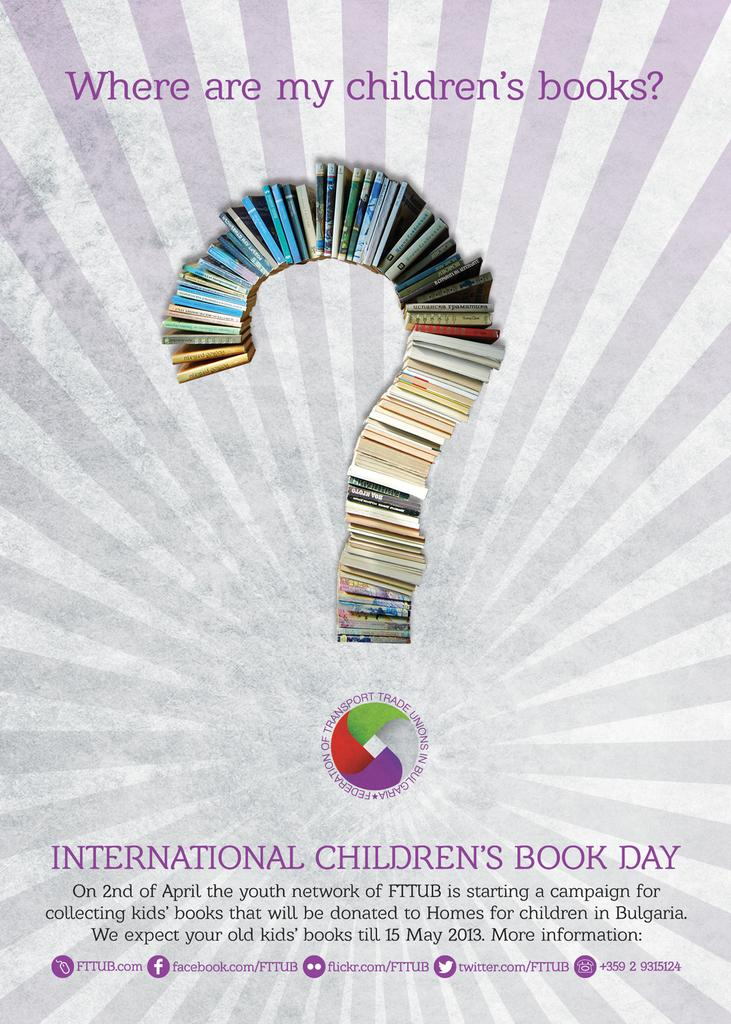<image>
Give a short and clear explanation of the subsequent image. A poster that is advertising international children's day. 